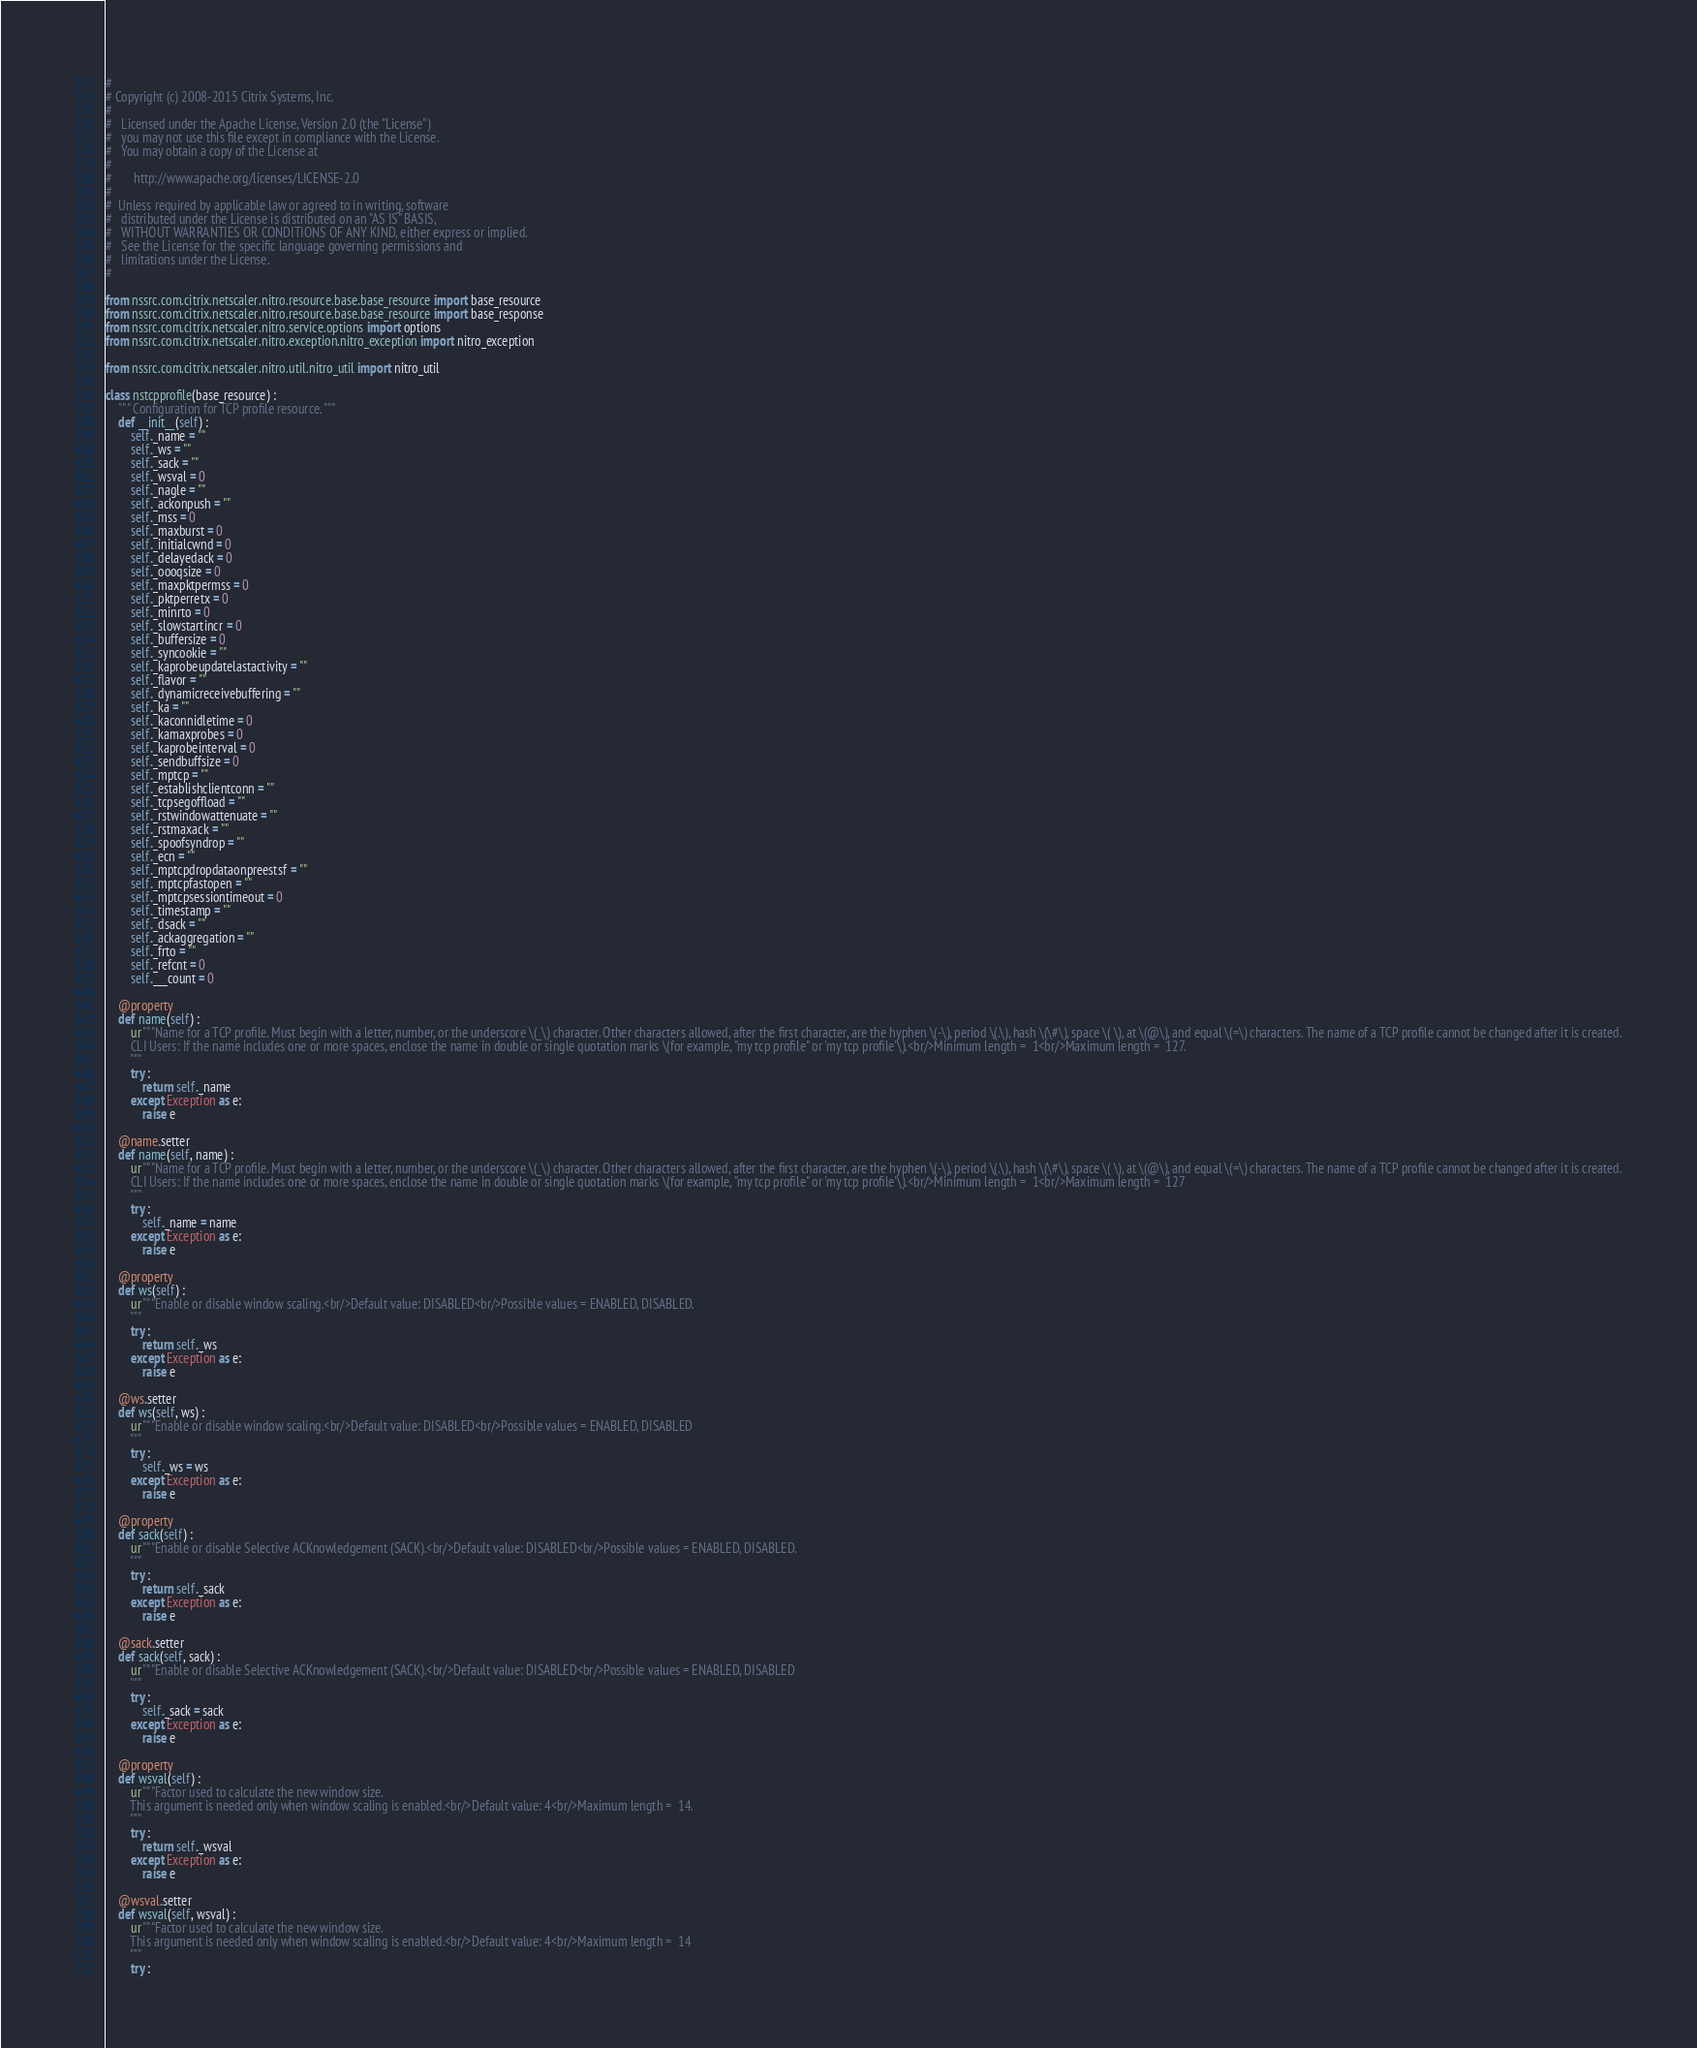<code> <loc_0><loc_0><loc_500><loc_500><_Python_>#
# Copyright (c) 2008-2015 Citrix Systems, Inc.
#
#   Licensed under the Apache License, Version 2.0 (the "License")
#   you may not use this file except in compliance with the License.
#   You may obtain a copy of the License at
#
#       http://www.apache.org/licenses/LICENSE-2.0
#
#  Unless required by applicable law or agreed to in writing, software
#   distributed under the License is distributed on an "AS IS" BASIS,
#   WITHOUT WARRANTIES OR CONDITIONS OF ANY KIND, either express or implied.
#   See the License for the specific language governing permissions and
#   limitations under the License.
#

from nssrc.com.citrix.netscaler.nitro.resource.base.base_resource import base_resource
from nssrc.com.citrix.netscaler.nitro.resource.base.base_resource import base_response
from nssrc.com.citrix.netscaler.nitro.service.options import options
from nssrc.com.citrix.netscaler.nitro.exception.nitro_exception import nitro_exception

from nssrc.com.citrix.netscaler.nitro.util.nitro_util import nitro_util

class nstcpprofile(base_resource) :
	""" Configuration for TCP profile resource. """
	def __init__(self) :
		self._name = ""
		self._ws = ""
		self._sack = ""
		self._wsval = 0
		self._nagle = ""
		self._ackonpush = ""
		self._mss = 0
		self._maxburst = 0
		self._initialcwnd = 0
		self._delayedack = 0
		self._oooqsize = 0
		self._maxpktpermss = 0
		self._pktperretx = 0
		self._minrto = 0
		self._slowstartincr = 0
		self._buffersize = 0
		self._syncookie = ""
		self._kaprobeupdatelastactivity = ""
		self._flavor = ""
		self._dynamicreceivebuffering = ""
		self._ka = ""
		self._kaconnidletime = 0
		self._kamaxprobes = 0
		self._kaprobeinterval = 0
		self._sendbuffsize = 0
		self._mptcp = ""
		self._establishclientconn = ""
		self._tcpsegoffload = ""
		self._rstwindowattenuate = ""
		self._rstmaxack = ""
		self._spoofsyndrop = ""
		self._ecn = ""
		self._mptcpdropdataonpreestsf = ""
		self._mptcpfastopen = ""
		self._mptcpsessiontimeout = 0
		self._timestamp = ""
		self._dsack = ""
		self._ackaggregation = ""
		self._frto = ""
		self._refcnt = 0
		self.___count = 0

	@property
	def name(self) :
		ur"""Name for a TCP profile. Must begin with a letter, number, or the underscore \(_\) character. Other characters allowed, after the first character, are the hyphen \(-\), period \(.\), hash \(\#\), space \( \), at \(@\), and equal \(=\) characters. The name of a TCP profile cannot be changed after it is created.
		CLI Users: If the name includes one or more spaces, enclose the name in double or single quotation marks \(for example, "my tcp profile" or 'my tcp profile'\).<br/>Minimum length =  1<br/>Maximum length =  127.
		"""
		try :
			return self._name
		except Exception as e:
			raise e

	@name.setter
	def name(self, name) :
		ur"""Name for a TCP profile. Must begin with a letter, number, or the underscore \(_\) character. Other characters allowed, after the first character, are the hyphen \(-\), period \(.\), hash \(\#\), space \( \), at \(@\), and equal \(=\) characters. The name of a TCP profile cannot be changed after it is created.
		CLI Users: If the name includes one or more spaces, enclose the name in double or single quotation marks \(for example, "my tcp profile" or 'my tcp profile'\).<br/>Minimum length =  1<br/>Maximum length =  127
		"""
		try :
			self._name = name
		except Exception as e:
			raise e

	@property
	def ws(self) :
		ur"""Enable or disable window scaling.<br/>Default value: DISABLED<br/>Possible values = ENABLED, DISABLED.
		"""
		try :
			return self._ws
		except Exception as e:
			raise e

	@ws.setter
	def ws(self, ws) :
		ur"""Enable or disable window scaling.<br/>Default value: DISABLED<br/>Possible values = ENABLED, DISABLED
		"""
		try :
			self._ws = ws
		except Exception as e:
			raise e

	@property
	def sack(self) :
		ur"""Enable or disable Selective ACKnowledgement (SACK).<br/>Default value: DISABLED<br/>Possible values = ENABLED, DISABLED.
		"""
		try :
			return self._sack
		except Exception as e:
			raise e

	@sack.setter
	def sack(self, sack) :
		ur"""Enable or disable Selective ACKnowledgement (SACK).<br/>Default value: DISABLED<br/>Possible values = ENABLED, DISABLED
		"""
		try :
			self._sack = sack
		except Exception as e:
			raise e

	@property
	def wsval(self) :
		ur"""Factor used to calculate the new window size.
		This argument is needed only when window scaling is enabled.<br/>Default value: 4<br/>Maximum length =  14.
		"""
		try :
			return self._wsval
		except Exception as e:
			raise e

	@wsval.setter
	def wsval(self, wsval) :
		ur"""Factor used to calculate the new window size.
		This argument is needed only when window scaling is enabled.<br/>Default value: 4<br/>Maximum length =  14
		"""
		try :</code> 